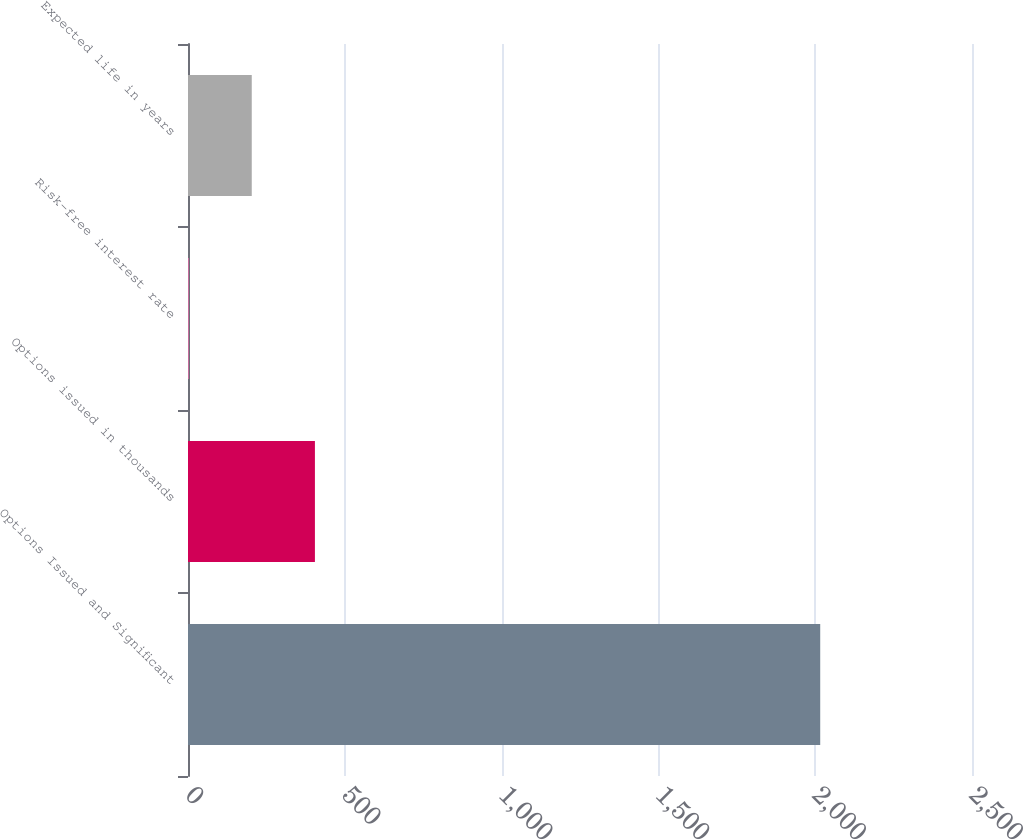Convert chart. <chart><loc_0><loc_0><loc_500><loc_500><bar_chart><fcel>Options Issued and Significant<fcel>Options issued in thousands<fcel>Risk-free interest rate<fcel>Expected life in years<nl><fcel>2016<fcel>404.72<fcel>1.9<fcel>203.31<nl></chart> 